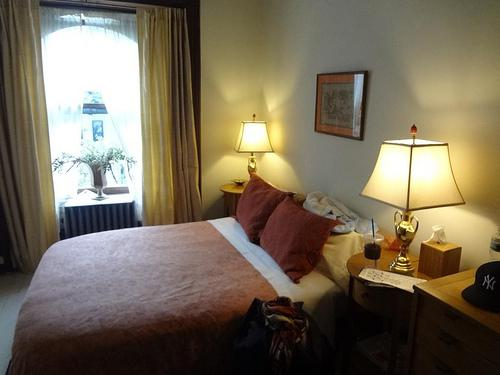Question: how many lamps are in the room?
Choices:
A. 1.
B. 3.
C. 2.
D. 4.
Answer with the letter. Answer: C Question: why was the picture taken?
Choices:
A. To capture the bedroom.
B. To capture the living room.
C. To capture the dining room.
D. To capture the yard.
Answer with the letter. Answer: A Question: where was the picture taken?
Choices:
A. In a living room.
B. In a bedroom.
C. In a bathroom.
D. In a kitchen.
Answer with the letter. Answer: B Question: when was the picture taken?
Choices:
A. During the morning.
B. During the evening.
C. At night.
D. During the day.
Answer with the letter. Answer: D 